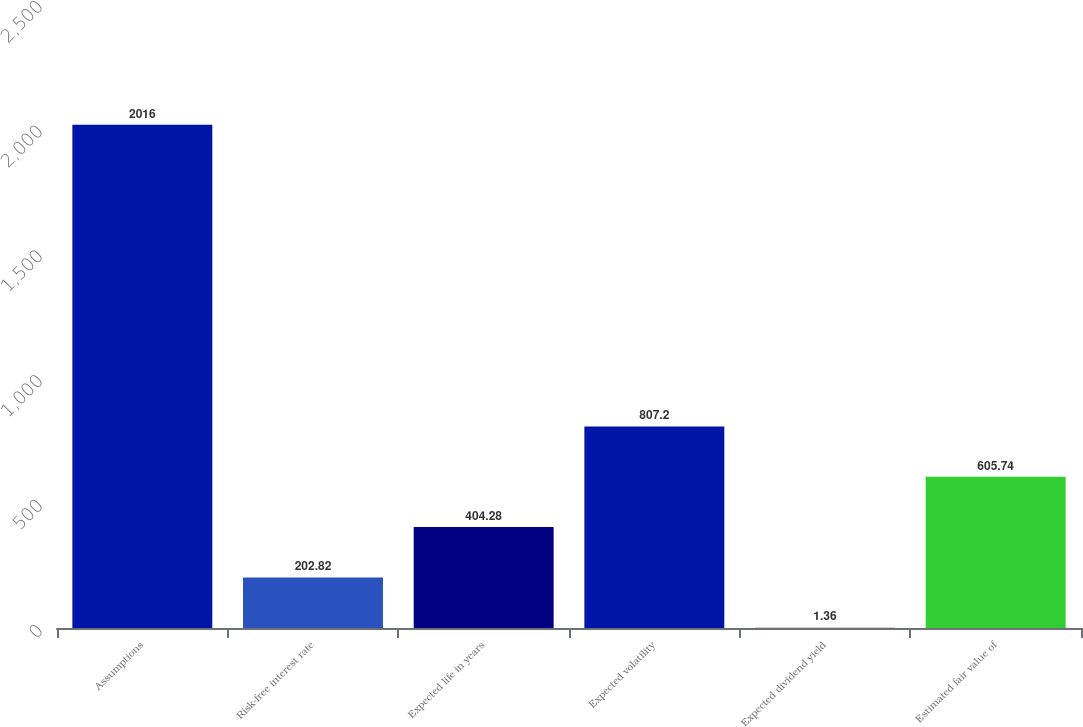Convert chart to OTSL. <chart><loc_0><loc_0><loc_500><loc_500><bar_chart><fcel>Assumptions<fcel>Risk-free interest rate<fcel>Expected life in years<fcel>Expected volatility<fcel>Expected dividend yield<fcel>Estimated fair value of<nl><fcel>2016<fcel>202.82<fcel>404.28<fcel>807.2<fcel>1.36<fcel>605.74<nl></chart> 